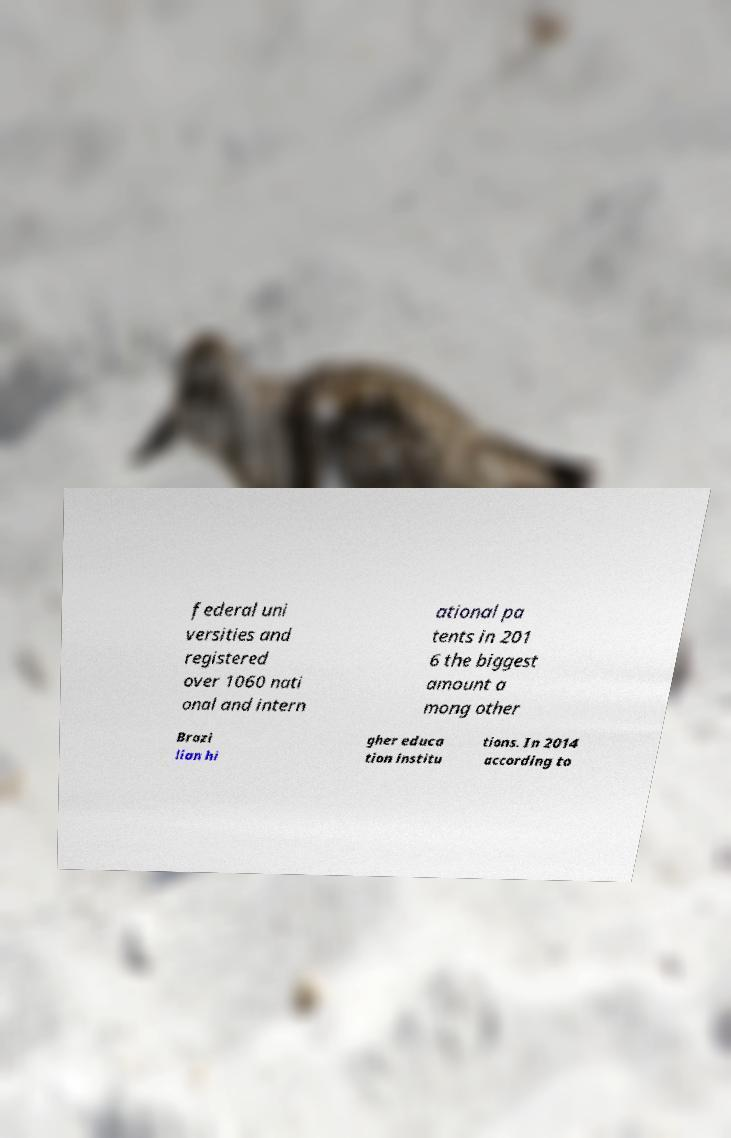Can you read and provide the text displayed in the image?This photo seems to have some interesting text. Can you extract and type it out for me? federal uni versities and registered over 1060 nati onal and intern ational pa tents in 201 6 the biggest amount a mong other Brazi lian hi gher educa tion institu tions. In 2014 according to 